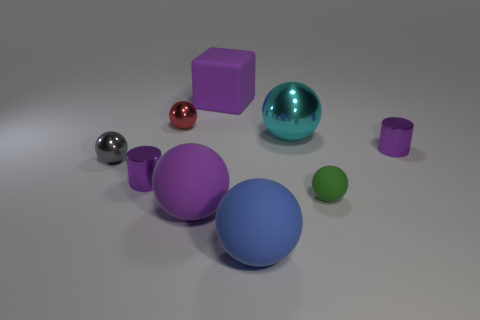There is a rubber object that is the same color as the cube; what is its size?
Your response must be concise. Large. What is the material of the block?
Provide a succinct answer. Rubber. Does the small matte ball have the same color as the big block?
Make the answer very short. No. Are there fewer big blue matte spheres that are in front of the blue ball than cyan spheres?
Provide a short and direct response. Yes. The cylinder left of the big blue thing is what color?
Your answer should be very brief. Purple. What is the shape of the big cyan metal object?
Ensure brevity in your answer.  Sphere. Is there a shiny object that is behind the tiny shiny cylinder in front of the cylinder right of the rubber cube?
Make the answer very short. Yes. There is a small shiny cylinder in front of the small metal ball that is to the left of the purple metallic thing in front of the gray thing; what color is it?
Your answer should be compact. Purple. There is a red thing that is the same shape as the gray metallic object; what is its material?
Your answer should be very brief. Metal. There is a metallic sphere that is on the right side of the big blue object that is in front of the cyan object; what size is it?
Ensure brevity in your answer.  Large. 